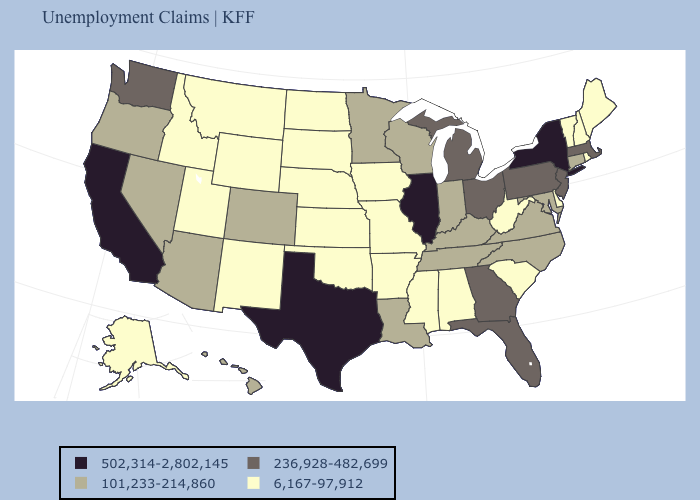Does California have the highest value in the USA?
Write a very short answer. Yes. Which states have the lowest value in the MidWest?
Give a very brief answer. Iowa, Kansas, Missouri, Nebraska, North Dakota, South Dakota. Name the states that have a value in the range 6,167-97,912?
Short answer required. Alabama, Alaska, Arkansas, Delaware, Idaho, Iowa, Kansas, Maine, Mississippi, Missouri, Montana, Nebraska, New Hampshire, New Mexico, North Dakota, Oklahoma, Rhode Island, South Carolina, South Dakota, Utah, Vermont, West Virginia, Wyoming. What is the value of Texas?
Keep it brief. 502,314-2,802,145. Does Illinois have a higher value than Nebraska?
Be succinct. Yes. What is the value of Ohio?
Concise answer only. 236,928-482,699. Name the states that have a value in the range 502,314-2,802,145?
Write a very short answer. California, Illinois, New York, Texas. What is the value of Montana?
Answer briefly. 6,167-97,912. Among the states that border Virginia , does West Virginia have the lowest value?
Write a very short answer. Yes. Name the states that have a value in the range 6,167-97,912?
Be succinct. Alabama, Alaska, Arkansas, Delaware, Idaho, Iowa, Kansas, Maine, Mississippi, Missouri, Montana, Nebraska, New Hampshire, New Mexico, North Dakota, Oklahoma, Rhode Island, South Carolina, South Dakota, Utah, Vermont, West Virginia, Wyoming. What is the value of Oklahoma?
Answer briefly. 6,167-97,912. Does the map have missing data?
Write a very short answer. No. Name the states that have a value in the range 236,928-482,699?
Write a very short answer. Florida, Georgia, Massachusetts, Michigan, New Jersey, Ohio, Pennsylvania, Washington. Does Kentucky have the highest value in the USA?
Quick response, please. No. Among the states that border Utah , does Nevada have the highest value?
Quick response, please. Yes. 